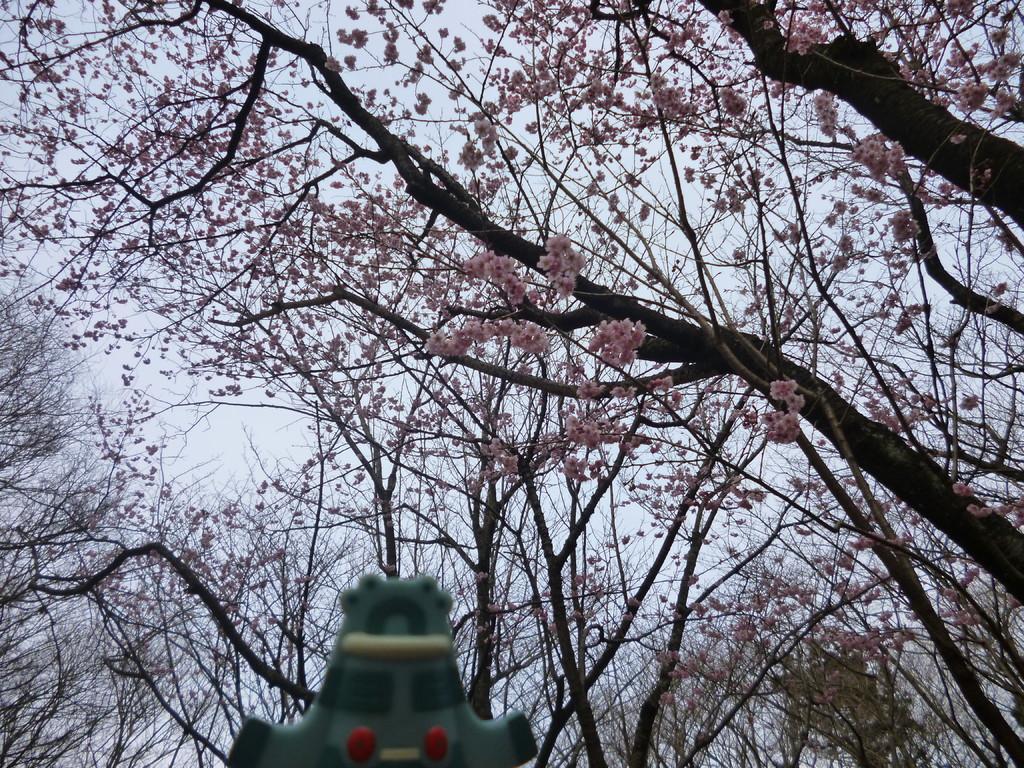In one or two sentences, can you explain what this image depicts? In this image there are few trees, a green color object and the sky. 